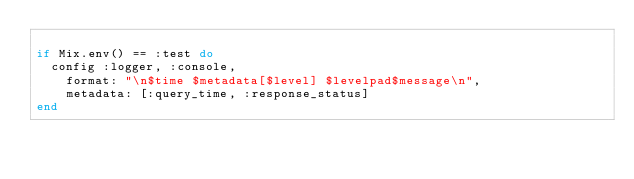Convert code to text. <code><loc_0><loc_0><loc_500><loc_500><_Elixir_>
if Mix.env() == :test do
  config :logger, :console,
    format: "\n$time $metadata[$level] $levelpad$message\n",
    metadata: [:query_time, :response_status]
end
</code> 